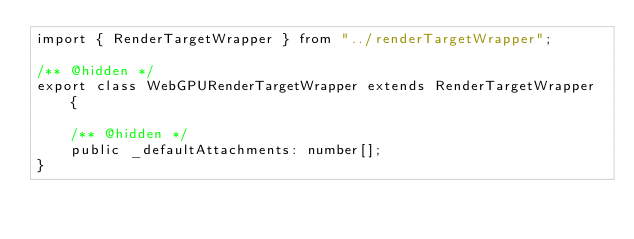Convert code to text. <code><loc_0><loc_0><loc_500><loc_500><_TypeScript_>import { RenderTargetWrapper } from "../renderTargetWrapper";

/** @hidden */
export class WebGPURenderTargetWrapper extends RenderTargetWrapper {

    /** @hidden */
    public _defaultAttachments: number[];
}
</code> 